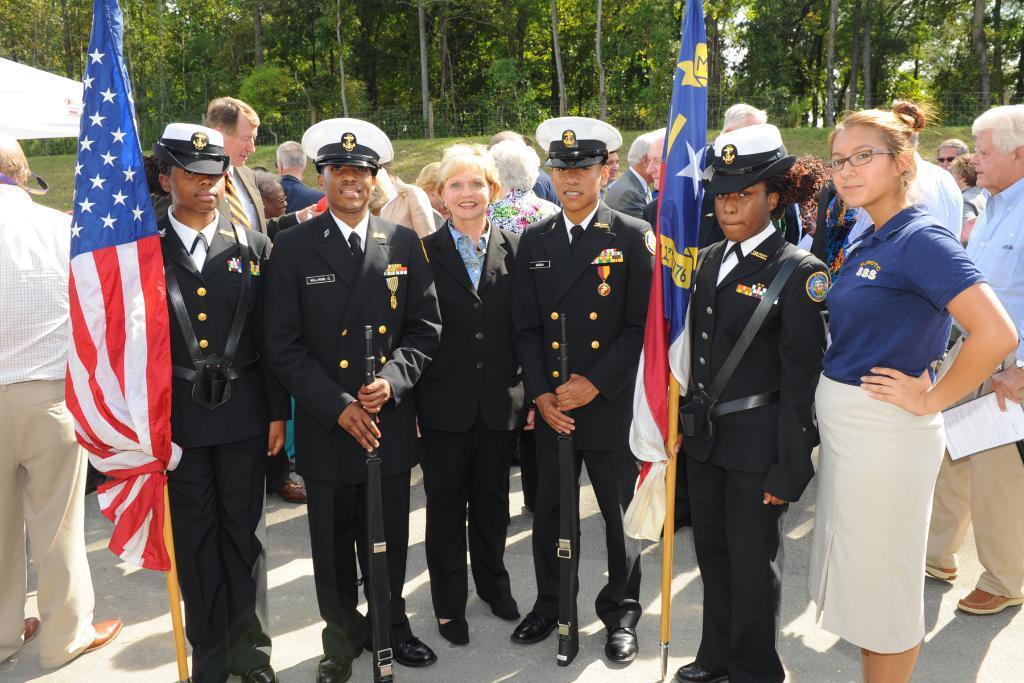How would you summarize this image in a sentence or two? In this image we can see few people wearing uniforms and there are two persons holding flags and behind we can see some people. There are some trees in the background. 